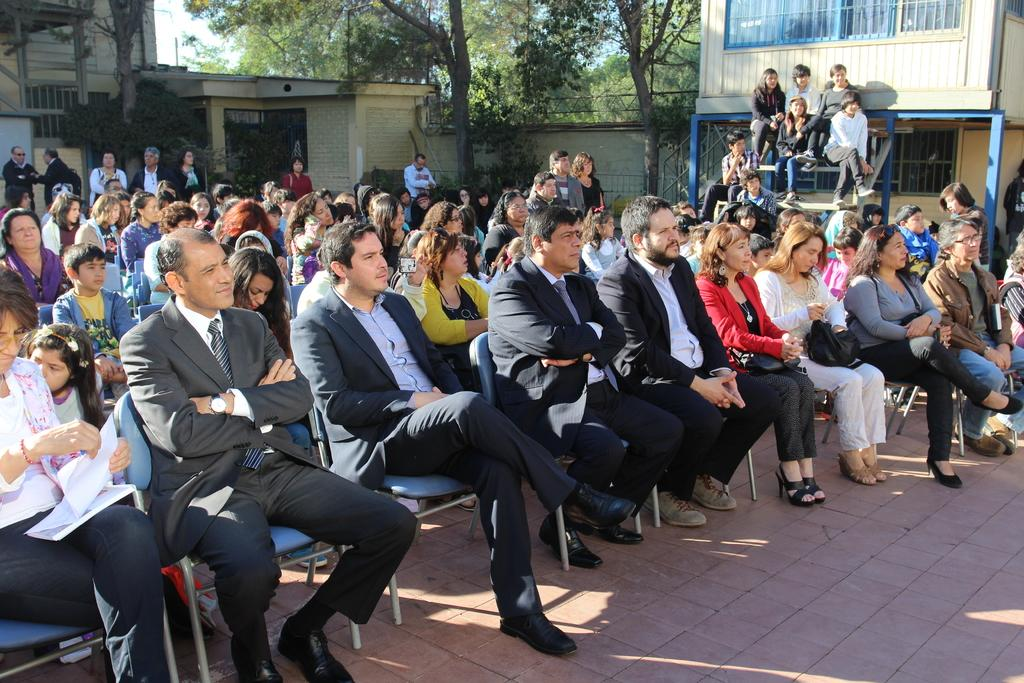What are the people in the image doing? There is a group of people sitting on chairs, and some people are standing on a path in the image. What can be seen in the background of the image? There are houses, trees, a wall, and the sky visible in the background of the image. What type of nerve can be seen in the image? There is no nerve present in the image; it features people sitting and standing, as well as background elements. 